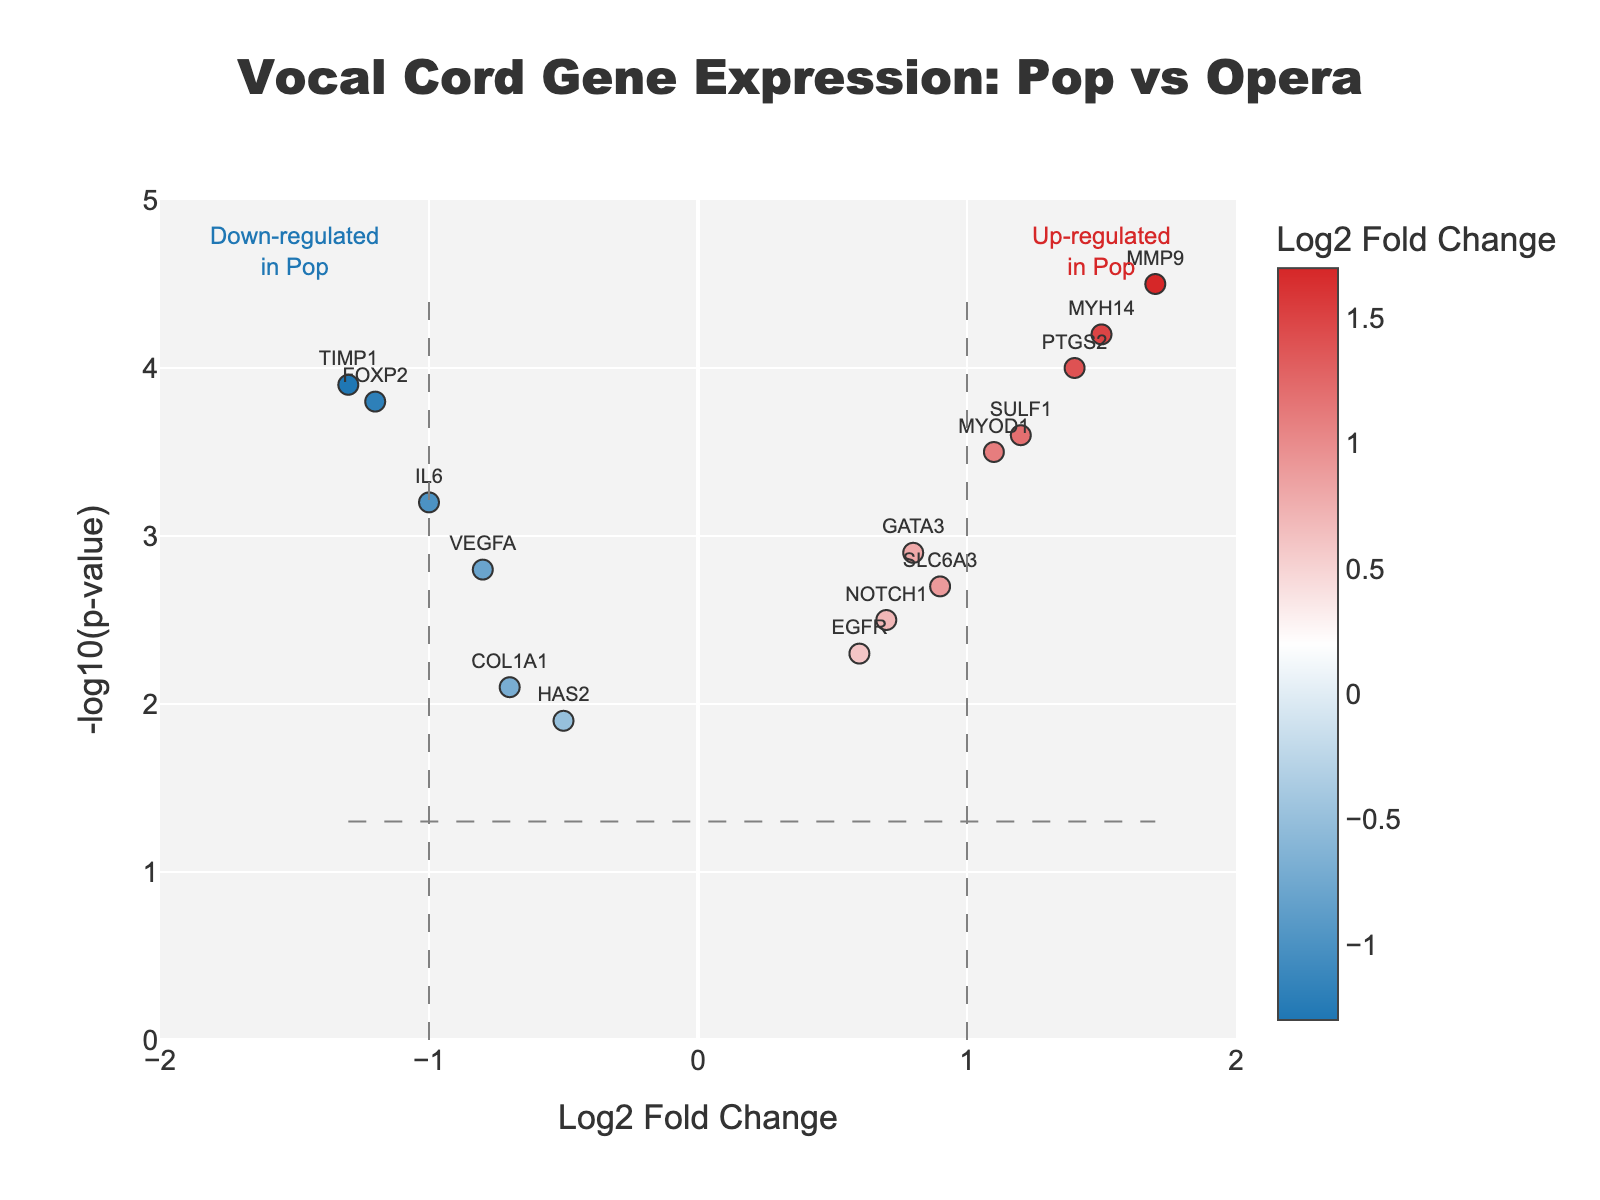How many genes are up-regulated in pop with a p-value less than 0.05? First, locate the genes that are in the right half of the plot (Log2FoldChange > 0) and above the horizontal threshold line (-log10(p-value) > 1.3). Count these genes.
Answer: 6 Which gene shows the highest up-regulation in pop? Look for the gene with the highest Log2FoldChange value on the right half of the plot. This will be the gene with the highest point on the right side.
Answer: MMP9 Among the down-regulated genes, which one has the lowest p-value? Find the down-regulated genes (Log2FoldChange < 0) and check their -log10(p-value). The gene with the highest -log10(p-value) (indicating the lowest p-value) is the answer.
Answer: TIMP1 What is the Log2FoldChange value of PTGS2? Locate the gene PTGS2 in the plot and read its corresponding Log2FoldChange value.
Answer: 1.4 What is the range of the p-values (in -log10(p-value)) for all the genes? Identify the lowest and highest -log10(p-value) values in the plot. The range is from the minimum to the maximum of these values.
Answer: 1.9 to 4.5 Which genes have a Log2FoldChange between -0.5 and 0.5? Look for the genes that fall within the range -0.5 < Log2FoldChange < 0.5 on the x-axis of the plot.
Answer: COL1A1, EGFR, HAS2, NOTCH1 Which gene has the closest p-value to the significance threshold of 0.05? Convert the threshold p-value (0.05) to -log10(p-value) = 1.3. Identify the gene whose -log10(p-value) is closest to 1.3.
Answer: HAS2 How many genes have a p-value greater than 0.01? Convert 0.01 to -log10(p-value) = 2. Identify and count the genes above this line.
Answer: 13 